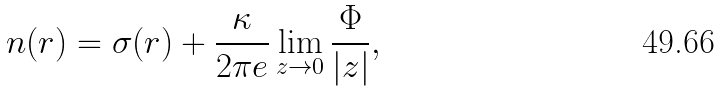<formula> <loc_0><loc_0><loc_500><loc_500>n ( r ) = \sigma ( r ) + \frac { \kappa } { 2 \pi e } \lim _ { z \to 0 } \frac { \Phi } { | z | } ,</formula> 